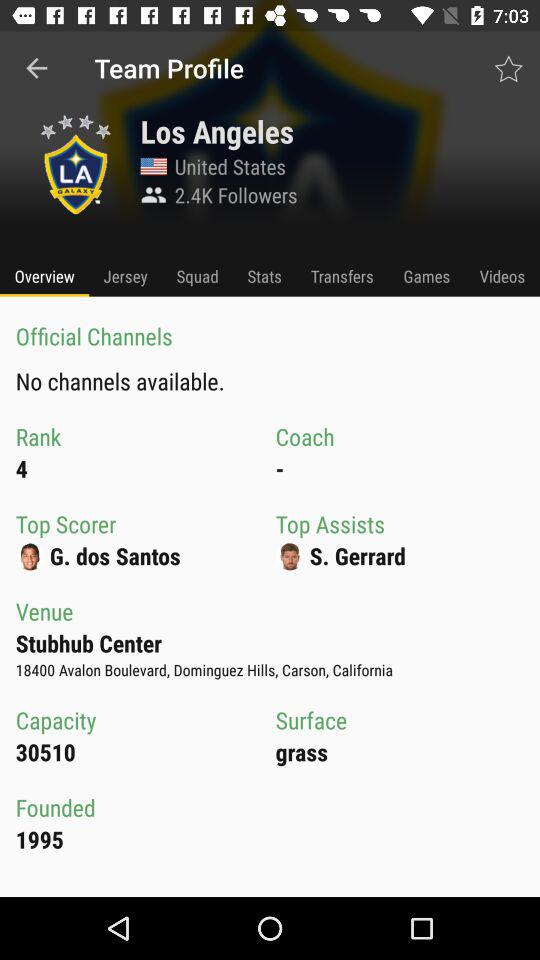How many channels are available? There are no available channels. 